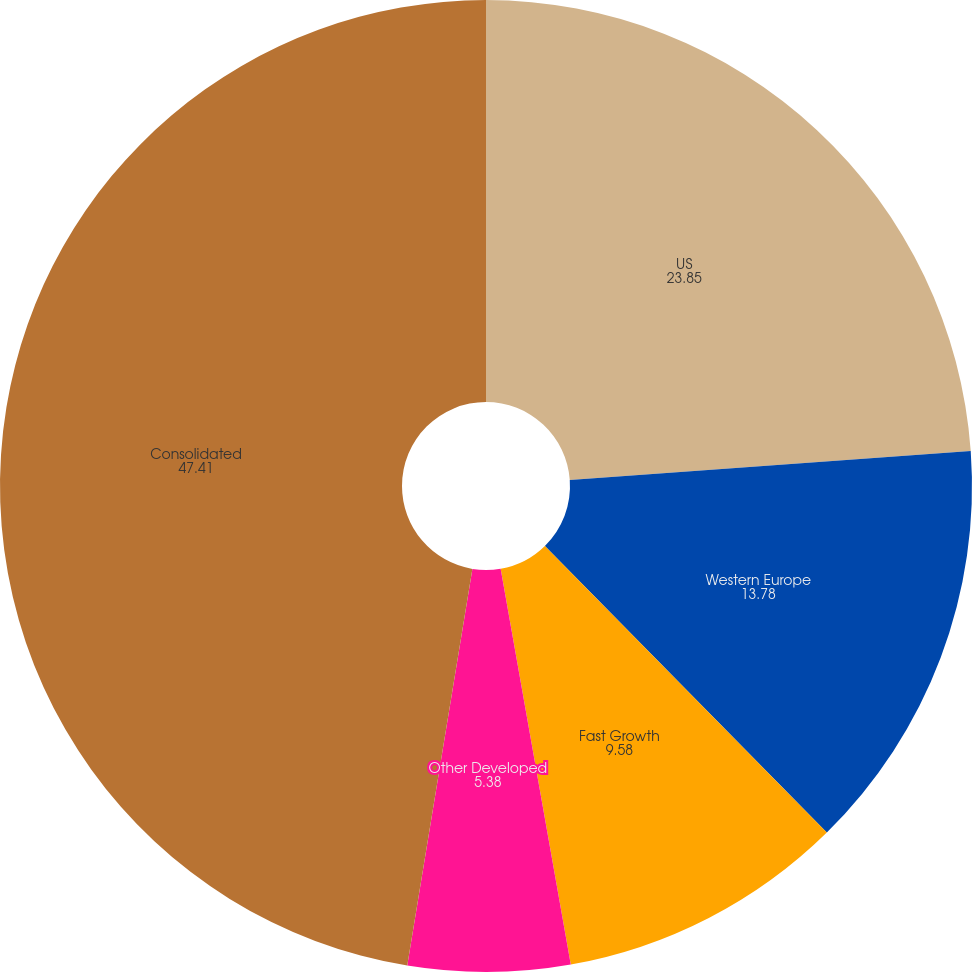Convert chart to OTSL. <chart><loc_0><loc_0><loc_500><loc_500><pie_chart><fcel>US<fcel>Western Europe<fcel>Fast Growth<fcel>Other Developed<fcel>Consolidated<nl><fcel>23.85%<fcel>13.78%<fcel>9.58%<fcel>5.38%<fcel>47.41%<nl></chart> 